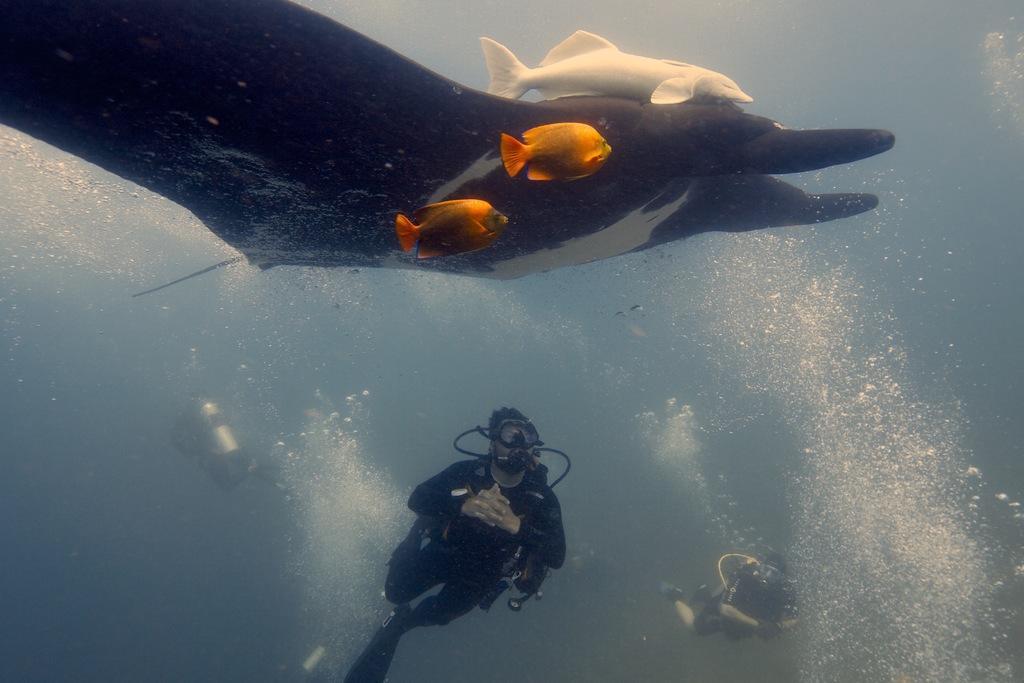Describe this image in one or two sentences. In this image there are three persons with cylinders are diving in the water, and there are fishes in the water. 